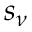<formula> <loc_0><loc_0><loc_500><loc_500>s _ { \nu }</formula> 